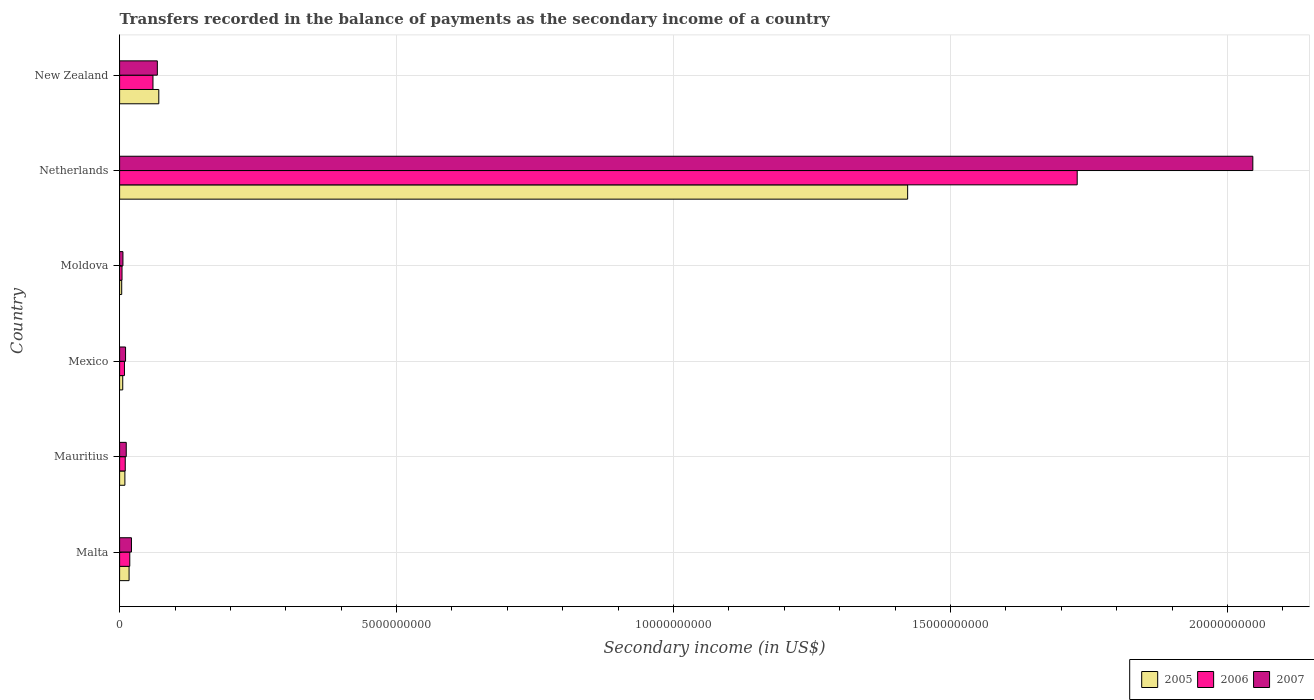How many different coloured bars are there?
Your answer should be compact. 3. How many groups of bars are there?
Your answer should be compact. 6. How many bars are there on the 6th tick from the top?
Your response must be concise. 3. What is the label of the 1st group of bars from the top?
Ensure brevity in your answer.  New Zealand. What is the secondary income of in 2005 in New Zealand?
Make the answer very short. 7.08e+08. Across all countries, what is the maximum secondary income of in 2005?
Offer a terse response. 1.42e+1. Across all countries, what is the minimum secondary income of in 2007?
Provide a succinct answer. 6.02e+07. In which country was the secondary income of in 2007 maximum?
Offer a very short reply. Netherlands. In which country was the secondary income of in 2005 minimum?
Your answer should be compact. Moldova. What is the total secondary income of in 2005 in the graph?
Give a very brief answer. 1.53e+1. What is the difference between the secondary income of in 2005 in Mauritius and that in Mexico?
Offer a very short reply. 3.88e+07. What is the difference between the secondary income of in 2005 in Mauritius and the secondary income of in 2007 in Malta?
Offer a terse response. -1.19e+08. What is the average secondary income of in 2007 per country?
Offer a terse response. 3.61e+09. What is the difference between the secondary income of in 2005 and secondary income of in 2006 in Mexico?
Give a very brief answer. -3.11e+07. What is the ratio of the secondary income of in 2006 in Mauritius to that in New Zealand?
Your answer should be very brief. 0.17. Is the secondary income of in 2006 in Moldova less than that in New Zealand?
Provide a short and direct response. Yes. What is the difference between the highest and the second highest secondary income of in 2007?
Give a very brief answer. 1.98e+1. What is the difference between the highest and the lowest secondary income of in 2005?
Your answer should be compact. 1.42e+1. In how many countries, is the secondary income of in 2006 greater than the average secondary income of in 2006 taken over all countries?
Ensure brevity in your answer.  1. What does the 2nd bar from the top in Mauritius represents?
Make the answer very short. 2006. What does the 1st bar from the bottom in Moldova represents?
Your answer should be very brief. 2005. Are all the bars in the graph horizontal?
Make the answer very short. Yes. What is the difference between two consecutive major ticks on the X-axis?
Ensure brevity in your answer.  5.00e+09. How many legend labels are there?
Your answer should be very brief. 3. What is the title of the graph?
Offer a very short reply. Transfers recorded in the balance of payments as the secondary income of a country. Does "1975" appear as one of the legend labels in the graph?
Provide a short and direct response. No. What is the label or title of the X-axis?
Your answer should be compact. Secondary income (in US$). What is the label or title of the Y-axis?
Keep it short and to the point. Country. What is the Secondary income (in US$) in 2005 in Malta?
Provide a short and direct response. 1.71e+08. What is the Secondary income (in US$) of 2006 in Malta?
Provide a short and direct response. 1.84e+08. What is the Secondary income (in US$) of 2007 in Malta?
Your response must be concise. 2.14e+08. What is the Secondary income (in US$) in 2005 in Mauritius?
Keep it short and to the point. 9.54e+07. What is the Secondary income (in US$) of 2006 in Mauritius?
Provide a succinct answer. 1.02e+08. What is the Secondary income (in US$) of 2007 in Mauritius?
Your answer should be very brief. 1.20e+08. What is the Secondary income (in US$) in 2005 in Mexico?
Your answer should be compact. 5.66e+07. What is the Secondary income (in US$) of 2006 in Mexico?
Your response must be concise. 8.77e+07. What is the Secondary income (in US$) in 2007 in Mexico?
Provide a short and direct response. 1.08e+08. What is the Secondary income (in US$) in 2005 in Moldova?
Make the answer very short. 3.79e+07. What is the Secondary income (in US$) in 2006 in Moldova?
Keep it short and to the point. 4.35e+07. What is the Secondary income (in US$) of 2007 in Moldova?
Offer a very short reply. 6.02e+07. What is the Secondary income (in US$) of 2005 in Netherlands?
Offer a very short reply. 1.42e+1. What is the Secondary income (in US$) of 2006 in Netherlands?
Make the answer very short. 1.73e+1. What is the Secondary income (in US$) in 2007 in Netherlands?
Ensure brevity in your answer.  2.05e+1. What is the Secondary income (in US$) in 2005 in New Zealand?
Make the answer very short. 7.08e+08. What is the Secondary income (in US$) in 2006 in New Zealand?
Offer a terse response. 6.02e+08. What is the Secondary income (in US$) in 2007 in New Zealand?
Offer a terse response. 6.81e+08. Across all countries, what is the maximum Secondary income (in US$) in 2005?
Your answer should be compact. 1.42e+1. Across all countries, what is the maximum Secondary income (in US$) of 2006?
Keep it short and to the point. 1.73e+1. Across all countries, what is the maximum Secondary income (in US$) in 2007?
Give a very brief answer. 2.05e+1. Across all countries, what is the minimum Secondary income (in US$) in 2005?
Give a very brief answer. 3.79e+07. Across all countries, what is the minimum Secondary income (in US$) of 2006?
Offer a terse response. 4.35e+07. Across all countries, what is the minimum Secondary income (in US$) in 2007?
Your response must be concise. 6.02e+07. What is the total Secondary income (in US$) of 2005 in the graph?
Provide a succinct answer. 1.53e+1. What is the total Secondary income (in US$) in 2006 in the graph?
Provide a short and direct response. 1.83e+1. What is the total Secondary income (in US$) in 2007 in the graph?
Your answer should be compact. 2.16e+1. What is the difference between the Secondary income (in US$) of 2005 in Malta and that in Mauritius?
Provide a succinct answer. 7.56e+07. What is the difference between the Secondary income (in US$) in 2006 in Malta and that in Mauritius?
Provide a short and direct response. 8.16e+07. What is the difference between the Secondary income (in US$) of 2007 in Malta and that in Mauritius?
Make the answer very short. 9.41e+07. What is the difference between the Secondary income (in US$) of 2005 in Malta and that in Mexico?
Keep it short and to the point. 1.14e+08. What is the difference between the Secondary income (in US$) in 2006 in Malta and that in Mexico?
Make the answer very short. 9.61e+07. What is the difference between the Secondary income (in US$) of 2007 in Malta and that in Mexico?
Your response must be concise. 1.06e+08. What is the difference between the Secondary income (in US$) of 2005 in Malta and that in Moldova?
Offer a terse response. 1.33e+08. What is the difference between the Secondary income (in US$) in 2006 in Malta and that in Moldova?
Provide a short and direct response. 1.40e+08. What is the difference between the Secondary income (in US$) of 2007 in Malta and that in Moldova?
Offer a very short reply. 1.54e+08. What is the difference between the Secondary income (in US$) in 2005 in Malta and that in Netherlands?
Your answer should be compact. -1.41e+1. What is the difference between the Secondary income (in US$) in 2006 in Malta and that in Netherlands?
Offer a very short reply. -1.71e+1. What is the difference between the Secondary income (in US$) of 2007 in Malta and that in Netherlands?
Ensure brevity in your answer.  -2.02e+1. What is the difference between the Secondary income (in US$) of 2005 in Malta and that in New Zealand?
Your answer should be very brief. -5.37e+08. What is the difference between the Secondary income (in US$) of 2006 in Malta and that in New Zealand?
Your answer should be compact. -4.19e+08. What is the difference between the Secondary income (in US$) of 2007 in Malta and that in New Zealand?
Keep it short and to the point. -4.67e+08. What is the difference between the Secondary income (in US$) in 2005 in Mauritius and that in Mexico?
Your answer should be compact. 3.88e+07. What is the difference between the Secondary income (in US$) of 2006 in Mauritius and that in Mexico?
Your answer should be compact. 1.44e+07. What is the difference between the Secondary income (in US$) in 2007 in Mauritius and that in Mexico?
Provide a succinct answer. 1.22e+07. What is the difference between the Secondary income (in US$) of 2005 in Mauritius and that in Moldova?
Your response must be concise. 5.76e+07. What is the difference between the Secondary income (in US$) of 2006 in Mauritius and that in Moldova?
Your answer should be very brief. 5.86e+07. What is the difference between the Secondary income (in US$) in 2007 in Mauritius and that in Moldova?
Offer a very short reply. 5.97e+07. What is the difference between the Secondary income (in US$) of 2005 in Mauritius and that in Netherlands?
Offer a very short reply. -1.41e+1. What is the difference between the Secondary income (in US$) of 2006 in Mauritius and that in Netherlands?
Make the answer very short. -1.72e+1. What is the difference between the Secondary income (in US$) in 2007 in Mauritius and that in Netherlands?
Provide a succinct answer. -2.03e+1. What is the difference between the Secondary income (in US$) of 2005 in Mauritius and that in New Zealand?
Offer a very short reply. -6.12e+08. What is the difference between the Secondary income (in US$) of 2006 in Mauritius and that in New Zealand?
Your answer should be very brief. -5.00e+08. What is the difference between the Secondary income (in US$) in 2007 in Mauritius and that in New Zealand?
Offer a terse response. -5.61e+08. What is the difference between the Secondary income (in US$) of 2005 in Mexico and that in Moldova?
Provide a short and direct response. 1.87e+07. What is the difference between the Secondary income (in US$) of 2006 in Mexico and that in Moldova?
Your answer should be very brief. 4.42e+07. What is the difference between the Secondary income (in US$) of 2007 in Mexico and that in Moldova?
Your response must be concise. 4.76e+07. What is the difference between the Secondary income (in US$) of 2005 in Mexico and that in Netherlands?
Keep it short and to the point. -1.42e+1. What is the difference between the Secondary income (in US$) of 2006 in Mexico and that in Netherlands?
Your response must be concise. -1.72e+1. What is the difference between the Secondary income (in US$) of 2007 in Mexico and that in Netherlands?
Ensure brevity in your answer.  -2.04e+1. What is the difference between the Secondary income (in US$) in 2005 in Mexico and that in New Zealand?
Your answer should be compact. -6.51e+08. What is the difference between the Secondary income (in US$) in 2006 in Mexico and that in New Zealand?
Ensure brevity in your answer.  -5.15e+08. What is the difference between the Secondary income (in US$) of 2007 in Mexico and that in New Zealand?
Provide a succinct answer. -5.74e+08. What is the difference between the Secondary income (in US$) in 2005 in Moldova and that in Netherlands?
Make the answer very short. -1.42e+1. What is the difference between the Secondary income (in US$) of 2006 in Moldova and that in Netherlands?
Your answer should be very brief. -1.72e+1. What is the difference between the Secondary income (in US$) in 2007 in Moldova and that in Netherlands?
Provide a short and direct response. -2.04e+1. What is the difference between the Secondary income (in US$) of 2005 in Moldova and that in New Zealand?
Offer a very short reply. -6.70e+08. What is the difference between the Secondary income (in US$) of 2006 in Moldova and that in New Zealand?
Offer a very short reply. -5.59e+08. What is the difference between the Secondary income (in US$) of 2007 in Moldova and that in New Zealand?
Offer a very short reply. -6.21e+08. What is the difference between the Secondary income (in US$) in 2005 in Netherlands and that in New Zealand?
Your answer should be compact. 1.35e+1. What is the difference between the Secondary income (in US$) of 2006 in Netherlands and that in New Zealand?
Give a very brief answer. 1.67e+1. What is the difference between the Secondary income (in US$) in 2007 in Netherlands and that in New Zealand?
Provide a succinct answer. 1.98e+1. What is the difference between the Secondary income (in US$) of 2005 in Malta and the Secondary income (in US$) of 2006 in Mauritius?
Make the answer very short. 6.89e+07. What is the difference between the Secondary income (in US$) of 2005 in Malta and the Secondary income (in US$) of 2007 in Mauritius?
Ensure brevity in your answer.  5.11e+07. What is the difference between the Secondary income (in US$) of 2006 in Malta and the Secondary income (in US$) of 2007 in Mauritius?
Give a very brief answer. 6.38e+07. What is the difference between the Secondary income (in US$) of 2005 in Malta and the Secondary income (in US$) of 2006 in Mexico?
Make the answer very short. 8.33e+07. What is the difference between the Secondary income (in US$) of 2005 in Malta and the Secondary income (in US$) of 2007 in Mexico?
Make the answer very short. 6.33e+07. What is the difference between the Secondary income (in US$) of 2006 in Malta and the Secondary income (in US$) of 2007 in Mexico?
Ensure brevity in your answer.  7.60e+07. What is the difference between the Secondary income (in US$) in 2005 in Malta and the Secondary income (in US$) in 2006 in Moldova?
Your answer should be compact. 1.28e+08. What is the difference between the Secondary income (in US$) in 2005 in Malta and the Secondary income (in US$) in 2007 in Moldova?
Your response must be concise. 1.11e+08. What is the difference between the Secondary income (in US$) of 2006 in Malta and the Secondary income (in US$) of 2007 in Moldova?
Keep it short and to the point. 1.24e+08. What is the difference between the Secondary income (in US$) of 2005 in Malta and the Secondary income (in US$) of 2006 in Netherlands?
Your answer should be very brief. -1.71e+1. What is the difference between the Secondary income (in US$) in 2005 in Malta and the Secondary income (in US$) in 2007 in Netherlands?
Ensure brevity in your answer.  -2.03e+1. What is the difference between the Secondary income (in US$) in 2006 in Malta and the Secondary income (in US$) in 2007 in Netherlands?
Provide a succinct answer. -2.03e+1. What is the difference between the Secondary income (in US$) of 2005 in Malta and the Secondary income (in US$) of 2006 in New Zealand?
Ensure brevity in your answer.  -4.31e+08. What is the difference between the Secondary income (in US$) in 2005 in Malta and the Secondary income (in US$) in 2007 in New Zealand?
Provide a short and direct response. -5.10e+08. What is the difference between the Secondary income (in US$) in 2006 in Malta and the Secondary income (in US$) in 2007 in New Zealand?
Make the answer very short. -4.98e+08. What is the difference between the Secondary income (in US$) of 2005 in Mauritius and the Secondary income (in US$) of 2006 in Mexico?
Keep it short and to the point. 7.79e+06. What is the difference between the Secondary income (in US$) in 2005 in Mauritius and the Secondary income (in US$) in 2007 in Mexico?
Your response must be concise. -1.23e+07. What is the difference between the Secondary income (in US$) in 2006 in Mauritius and the Secondary income (in US$) in 2007 in Mexico?
Offer a terse response. -5.61e+06. What is the difference between the Secondary income (in US$) of 2005 in Mauritius and the Secondary income (in US$) of 2006 in Moldova?
Your answer should be compact. 5.20e+07. What is the difference between the Secondary income (in US$) in 2005 in Mauritius and the Secondary income (in US$) in 2007 in Moldova?
Offer a terse response. 3.53e+07. What is the difference between the Secondary income (in US$) in 2006 in Mauritius and the Secondary income (in US$) in 2007 in Moldova?
Make the answer very short. 4.19e+07. What is the difference between the Secondary income (in US$) of 2005 in Mauritius and the Secondary income (in US$) of 2006 in Netherlands?
Offer a terse response. -1.72e+1. What is the difference between the Secondary income (in US$) in 2005 in Mauritius and the Secondary income (in US$) in 2007 in Netherlands?
Make the answer very short. -2.04e+1. What is the difference between the Secondary income (in US$) in 2006 in Mauritius and the Secondary income (in US$) in 2007 in Netherlands?
Your answer should be compact. -2.04e+1. What is the difference between the Secondary income (in US$) in 2005 in Mauritius and the Secondary income (in US$) in 2006 in New Zealand?
Provide a short and direct response. -5.07e+08. What is the difference between the Secondary income (in US$) in 2005 in Mauritius and the Secondary income (in US$) in 2007 in New Zealand?
Make the answer very short. -5.86e+08. What is the difference between the Secondary income (in US$) of 2006 in Mauritius and the Secondary income (in US$) of 2007 in New Zealand?
Provide a short and direct response. -5.79e+08. What is the difference between the Secondary income (in US$) of 2005 in Mexico and the Secondary income (in US$) of 2006 in Moldova?
Offer a terse response. 1.31e+07. What is the difference between the Secondary income (in US$) of 2005 in Mexico and the Secondary income (in US$) of 2007 in Moldova?
Offer a terse response. -3.56e+06. What is the difference between the Secondary income (in US$) in 2006 in Mexico and the Secondary income (in US$) in 2007 in Moldova?
Give a very brief answer. 2.75e+07. What is the difference between the Secondary income (in US$) of 2005 in Mexico and the Secondary income (in US$) of 2006 in Netherlands?
Provide a succinct answer. -1.72e+1. What is the difference between the Secondary income (in US$) in 2005 in Mexico and the Secondary income (in US$) in 2007 in Netherlands?
Your answer should be compact. -2.04e+1. What is the difference between the Secondary income (in US$) in 2006 in Mexico and the Secondary income (in US$) in 2007 in Netherlands?
Provide a short and direct response. -2.04e+1. What is the difference between the Secondary income (in US$) in 2005 in Mexico and the Secondary income (in US$) in 2006 in New Zealand?
Give a very brief answer. -5.46e+08. What is the difference between the Secondary income (in US$) in 2005 in Mexico and the Secondary income (in US$) in 2007 in New Zealand?
Provide a succinct answer. -6.25e+08. What is the difference between the Secondary income (in US$) of 2006 in Mexico and the Secondary income (in US$) of 2007 in New Zealand?
Give a very brief answer. -5.94e+08. What is the difference between the Secondary income (in US$) of 2005 in Moldova and the Secondary income (in US$) of 2006 in Netherlands?
Provide a short and direct response. -1.72e+1. What is the difference between the Secondary income (in US$) of 2005 in Moldova and the Secondary income (in US$) of 2007 in Netherlands?
Provide a succinct answer. -2.04e+1. What is the difference between the Secondary income (in US$) in 2006 in Moldova and the Secondary income (in US$) in 2007 in Netherlands?
Ensure brevity in your answer.  -2.04e+1. What is the difference between the Secondary income (in US$) in 2005 in Moldova and the Secondary income (in US$) in 2006 in New Zealand?
Make the answer very short. -5.65e+08. What is the difference between the Secondary income (in US$) in 2005 in Moldova and the Secondary income (in US$) in 2007 in New Zealand?
Offer a very short reply. -6.43e+08. What is the difference between the Secondary income (in US$) in 2006 in Moldova and the Secondary income (in US$) in 2007 in New Zealand?
Provide a short and direct response. -6.38e+08. What is the difference between the Secondary income (in US$) in 2005 in Netherlands and the Secondary income (in US$) in 2006 in New Zealand?
Ensure brevity in your answer.  1.36e+1. What is the difference between the Secondary income (in US$) of 2005 in Netherlands and the Secondary income (in US$) of 2007 in New Zealand?
Your answer should be very brief. 1.35e+1. What is the difference between the Secondary income (in US$) of 2006 in Netherlands and the Secondary income (in US$) of 2007 in New Zealand?
Offer a terse response. 1.66e+1. What is the average Secondary income (in US$) in 2005 per country?
Your answer should be very brief. 2.55e+09. What is the average Secondary income (in US$) of 2006 per country?
Make the answer very short. 3.05e+09. What is the average Secondary income (in US$) in 2007 per country?
Your answer should be very brief. 3.61e+09. What is the difference between the Secondary income (in US$) in 2005 and Secondary income (in US$) in 2006 in Malta?
Your answer should be very brief. -1.27e+07. What is the difference between the Secondary income (in US$) of 2005 and Secondary income (in US$) of 2007 in Malta?
Offer a terse response. -4.30e+07. What is the difference between the Secondary income (in US$) of 2006 and Secondary income (in US$) of 2007 in Malta?
Your answer should be very brief. -3.03e+07. What is the difference between the Secondary income (in US$) in 2005 and Secondary income (in US$) in 2006 in Mauritius?
Ensure brevity in your answer.  -6.65e+06. What is the difference between the Secondary income (in US$) of 2005 and Secondary income (in US$) of 2007 in Mauritius?
Keep it short and to the point. -2.45e+07. What is the difference between the Secondary income (in US$) of 2006 and Secondary income (in US$) of 2007 in Mauritius?
Offer a very short reply. -1.78e+07. What is the difference between the Secondary income (in US$) of 2005 and Secondary income (in US$) of 2006 in Mexico?
Offer a very short reply. -3.11e+07. What is the difference between the Secondary income (in US$) in 2005 and Secondary income (in US$) in 2007 in Mexico?
Your response must be concise. -5.11e+07. What is the difference between the Secondary income (in US$) in 2006 and Secondary income (in US$) in 2007 in Mexico?
Provide a short and direct response. -2.01e+07. What is the difference between the Secondary income (in US$) of 2005 and Secondary income (in US$) of 2006 in Moldova?
Your answer should be compact. -5.60e+06. What is the difference between the Secondary income (in US$) in 2005 and Secondary income (in US$) in 2007 in Moldova?
Offer a terse response. -2.23e+07. What is the difference between the Secondary income (in US$) in 2006 and Secondary income (in US$) in 2007 in Moldova?
Give a very brief answer. -1.67e+07. What is the difference between the Secondary income (in US$) in 2005 and Secondary income (in US$) in 2006 in Netherlands?
Offer a terse response. -3.06e+09. What is the difference between the Secondary income (in US$) of 2005 and Secondary income (in US$) of 2007 in Netherlands?
Your response must be concise. -6.23e+09. What is the difference between the Secondary income (in US$) in 2006 and Secondary income (in US$) in 2007 in Netherlands?
Ensure brevity in your answer.  -3.17e+09. What is the difference between the Secondary income (in US$) in 2005 and Secondary income (in US$) in 2006 in New Zealand?
Your answer should be compact. 1.05e+08. What is the difference between the Secondary income (in US$) of 2005 and Secondary income (in US$) of 2007 in New Zealand?
Provide a short and direct response. 2.63e+07. What is the difference between the Secondary income (in US$) of 2006 and Secondary income (in US$) of 2007 in New Zealand?
Your answer should be very brief. -7.89e+07. What is the ratio of the Secondary income (in US$) of 2005 in Malta to that in Mauritius?
Your response must be concise. 1.79. What is the ratio of the Secondary income (in US$) of 2006 in Malta to that in Mauritius?
Offer a terse response. 1.8. What is the ratio of the Secondary income (in US$) of 2007 in Malta to that in Mauritius?
Offer a terse response. 1.78. What is the ratio of the Secondary income (in US$) of 2005 in Malta to that in Mexico?
Provide a short and direct response. 3.02. What is the ratio of the Secondary income (in US$) of 2006 in Malta to that in Mexico?
Ensure brevity in your answer.  2.1. What is the ratio of the Secondary income (in US$) of 2007 in Malta to that in Mexico?
Give a very brief answer. 1.99. What is the ratio of the Secondary income (in US$) of 2005 in Malta to that in Moldova?
Offer a terse response. 4.52. What is the ratio of the Secondary income (in US$) in 2006 in Malta to that in Moldova?
Your answer should be very brief. 4.23. What is the ratio of the Secondary income (in US$) of 2007 in Malta to that in Moldova?
Give a very brief answer. 3.56. What is the ratio of the Secondary income (in US$) in 2005 in Malta to that in Netherlands?
Ensure brevity in your answer.  0.01. What is the ratio of the Secondary income (in US$) in 2006 in Malta to that in Netherlands?
Your answer should be compact. 0.01. What is the ratio of the Secondary income (in US$) in 2007 in Malta to that in Netherlands?
Offer a very short reply. 0.01. What is the ratio of the Secondary income (in US$) in 2005 in Malta to that in New Zealand?
Keep it short and to the point. 0.24. What is the ratio of the Secondary income (in US$) of 2006 in Malta to that in New Zealand?
Offer a very short reply. 0.3. What is the ratio of the Secondary income (in US$) of 2007 in Malta to that in New Zealand?
Your answer should be compact. 0.31. What is the ratio of the Secondary income (in US$) in 2005 in Mauritius to that in Mexico?
Provide a succinct answer. 1.69. What is the ratio of the Secondary income (in US$) in 2006 in Mauritius to that in Mexico?
Provide a succinct answer. 1.16. What is the ratio of the Secondary income (in US$) of 2007 in Mauritius to that in Mexico?
Give a very brief answer. 1.11. What is the ratio of the Secondary income (in US$) in 2005 in Mauritius to that in Moldova?
Provide a succinct answer. 2.52. What is the ratio of the Secondary income (in US$) in 2006 in Mauritius to that in Moldova?
Your response must be concise. 2.35. What is the ratio of the Secondary income (in US$) of 2007 in Mauritius to that in Moldova?
Keep it short and to the point. 1.99. What is the ratio of the Secondary income (in US$) in 2005 in Mauritius to that in Netherlands?
Make the answer very short. 0.01. What is the ratio of the Secondary income (in US$) of 2006 in Mauritius to that in Netherlands?
Provide a succinct answer. 0.01. What is the ratio of the Secondary income (in US$) of 2007 in Mauritius to that in Netherlands?
Provide a succinct answer. 0.01. What is the ratio of the Secondary income (in US$) in 2005 in Mauritius to that in New Zealand?
Provide a succinct answer. 0.13. What is the ratio of the Secondary income (in US$) in 2006 in Mauritius to that in New Zealand?
Provide a short and direct response. 0.17. What is the ratio of the Secondary income (in US$) of 2007 in Mauritius to that in New Zealand?
Provide a succinct answer. 0.18. What is the ratio of the Secondary income (in US$) of 2005 in Mexico to that in Moldova?
Give a very brief answer. 1.49. What is the ratio of the Secondary income (in US$) in 2006 in Mexico to that in Moldova?
Make the answer very short. 2.02. What is the ratio of the Secondary income (in US$) of 2007 in Mexico to that in Moldova?
Offer a very short reply. 1.79. What is the ratio of the Secondary income (in US$) in 2005 in Mexico to that in Netherlands?
Make the answer very short. 0. What is the ratio of the Secondary income (in US$) in 2006 in Mexico to that in Netherlands?
Your answer should be very brief. 0.01. What is the ratio of the Secondary income (in US$) in 2007 in Mexico to that in Netherlands?
Give a very brief answer. 0.01. What is the ratio of the Secondary income (in US$) in 2005 in Mexico to that in New Zealand?
Provide a succinct answer. 0.08. What is the ratio of the Secondary income (in US$) in 2006 in Mexico to that in New Zealand?
Keep it short and to the point. 0.15. What is the ratio of the Secondary income (in US$) in 2007 in Mexico to that in New Zealand?
Offer a terse response. 0.16. What is the ratio of the Secondary income (in US$) in 2005 in Moldova to that in Netherlands?
Your answer should be compact. 0. What is the ratio of the Secondary income (in US$) in 2006 in Moldova to that in Netherlands?
Offer a very short reply. 0. What is the ratio of the Secondary income (in US$) in 2007 in Moldova to that in Netherlands?
Your answer should be compact. 0. What is the ratio of the Secondary income (in US$) of 2005 in Moldova to that in New Zealand?
Keep it short and to the point. 0.05. What is the ratio of the Secondary income (in US$) of 2006 in Moldova to that in New Zealand?
Provide a succinct answer. 0.07. What is the ratio of the Secondary income (in US$) of 2007 in Moldova to that in New Zealand?
Ensure brevity in your answer.  0.09. What is the ratio of the Secondary income (in US$) of 2005 in Netherlands to that in New Zealand?
Ensure brevity in your answer.  20.11. What is the ratio of the Secondary income (in US$) in 2006 in Netherlands to that in New Zealand?
Your answer should be compact. 28.7. What is the ratio of the Secondary income (in US$) of 2007 in Netherlands to that in New Zealand?
Ensure brevity in your answer.  30.03. What is the difference between the highest and the second highest Secondary income (in US$) of 2005?
Ensure brevity in your answer.  1.35e+1. What is the difference between the highest and the second highest Secondary income (in US$) in 2006?
Make the answer very short. 1.67e+1. What is the difference between the highest and the second highest Secondary income (in US$) in 2007?
Offer a terse response. 1.98e+1. What is the difference between the highest and the lowest Secondary income (in US$) in 2005?
Keep it short and to the point. 1.42e+1. What is the difference between the highest and the lowest Secondary income (in US$) of 2006?
Provide a short and direct response. 1.72e+1. What is the difference between the highest and the lowest Secondary income (in US$) in 2007?
Provide a succinct answer. 2.04e+1. 